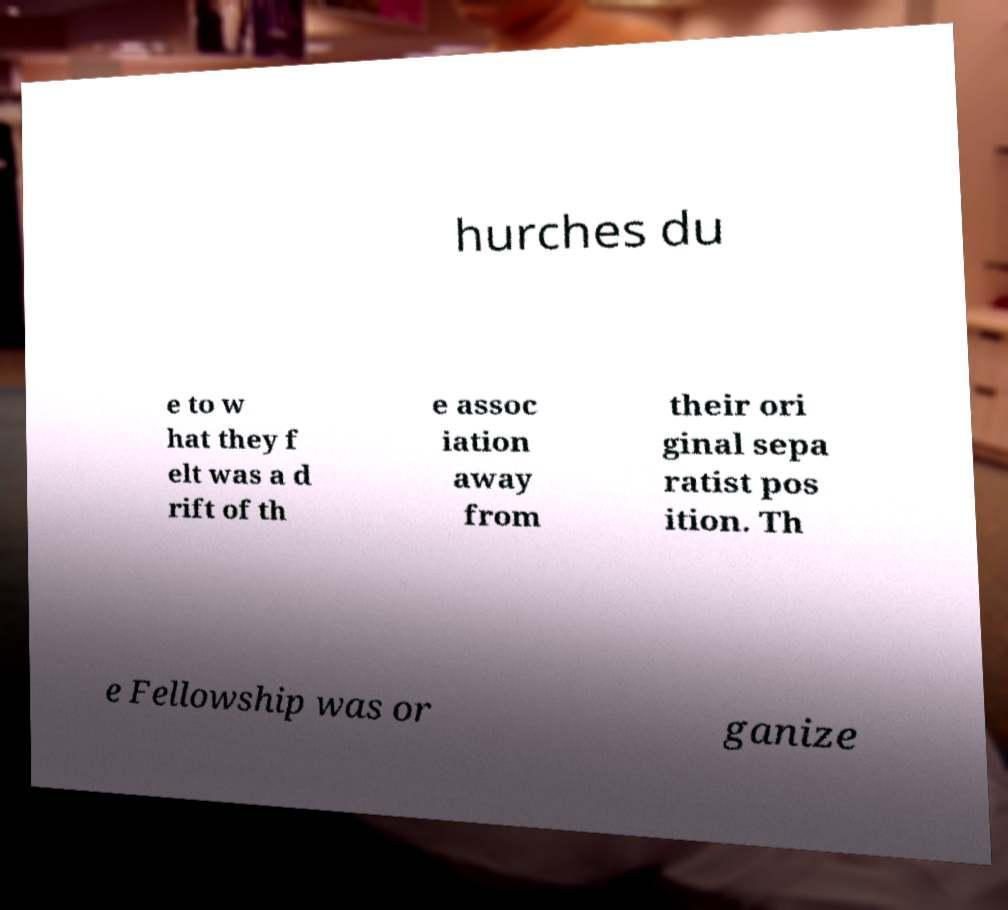I need the written content from this picture converted into text. Can you do that? hurches du e to w hat they f elt was a d rift of th e assoc iation away from their ori ginal sepa ratist pos ition. Th e Fellowship was or ganize 